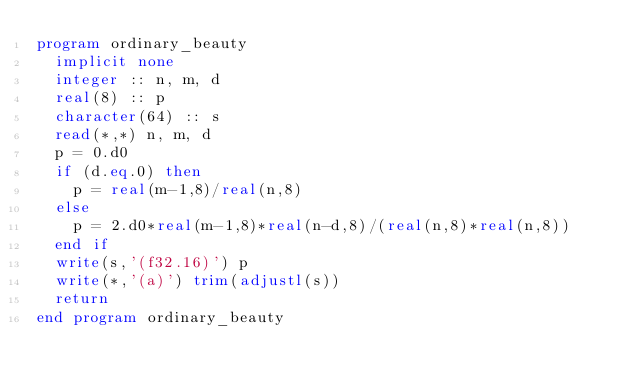<code> <loc_0><loc_0><loc_500><loc_500><_FORTRAN_>program ordinary_beauty
  implicit none
  integer :: n, m, d
  real(8) :: p
  character(64) :: s
  read(*,*) n, m, d
  p = 0.d0
  if (d.eq.0) then
    p = real(m-1,8)/real(n,8)
  else
    p = 2.d0*real(m-1,8)*real(n-d,8)/(real(n,8)*real(n,8))
  end if
  write(s,'(f32.16)') p
  write(*,'(a)') trim(adjustl(s))
  return
end program ordinary_beauty</code> 